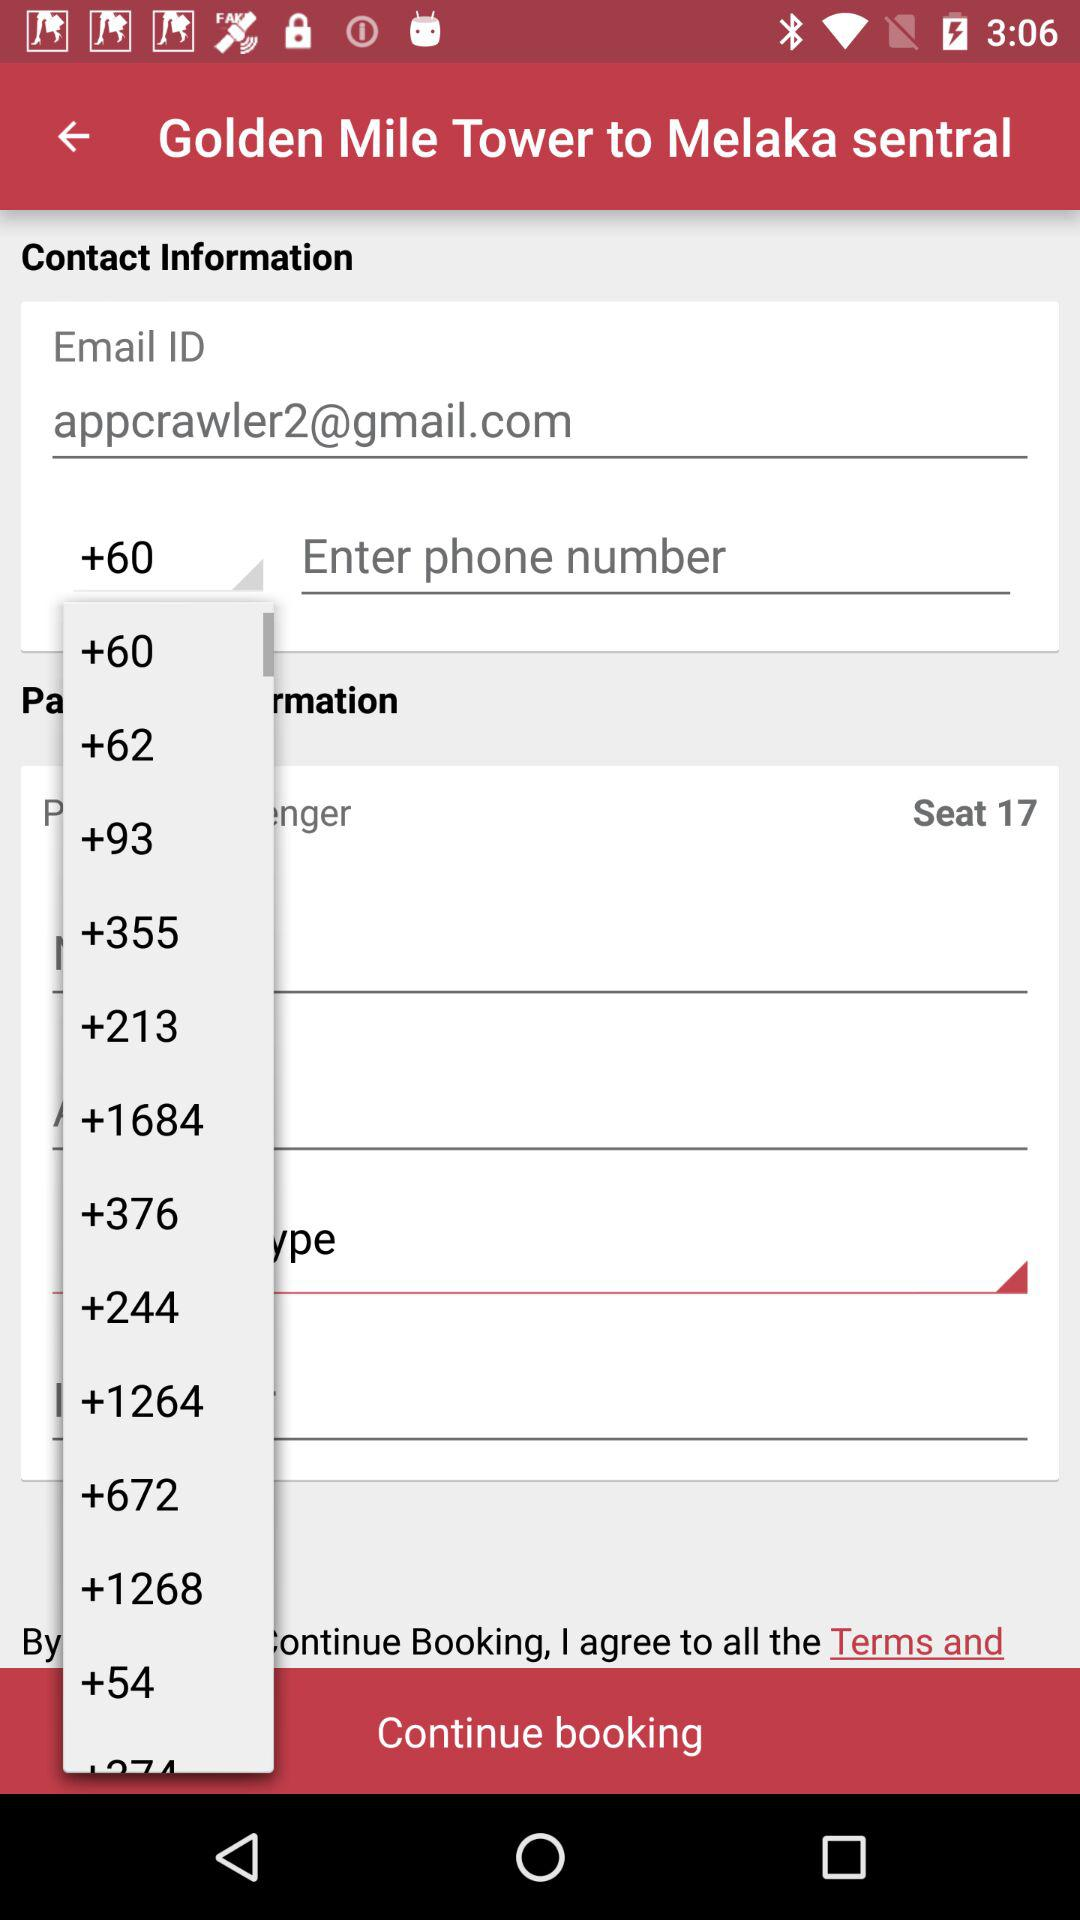What is the selected country code? The selected country code is +60. 